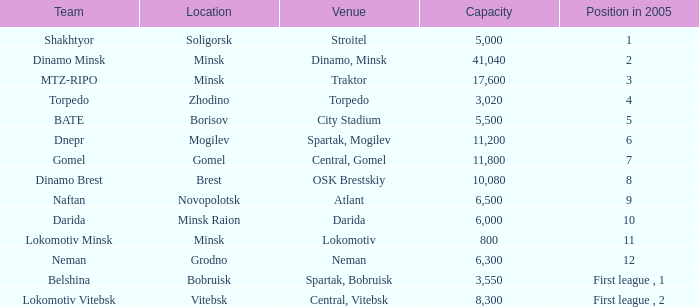What is the capacity associated with a position of 8 during 2005? 10080.0. 